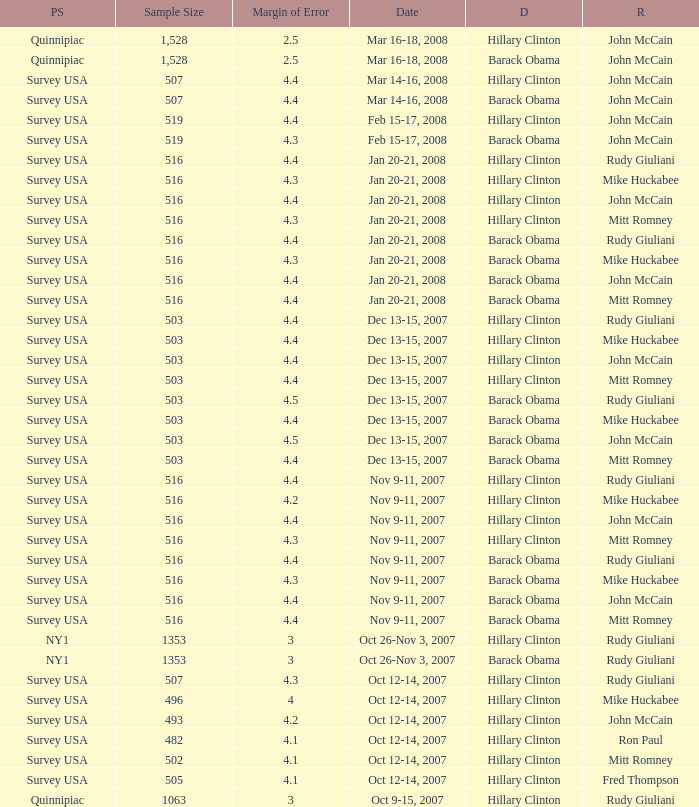Which Democrat was selected in the poll with a sample size smaller than 516 where the Republican chosen was Ron Paul? Hillary Clinton. Can you parse all the data within this table? {'header': ['PS', 'Sample Size', 'Margin of Error', 'Date', 'D', 'R'], 'rows': [['Quinnipiac', '1,528', '2.5', 'Mar 16-18, 2008', 'Hillary Clinton', 'John McCain'], ['Quinnipiac', '1,528', '2.5', 'Mar 16-18, 2008', 'Barack Obama', 'John McCain'], ['Survey USA', '507', '4.4', 'Mar 14-16, 2008', 'Hillary Clinton', 'John McCain'], ['Survey USA', '507', '4.4', 'Mar 14-16, 2008', 'Barack Obama', 'John McCain'], ['Survey USA', '519', '4.4', 'Feb 15-17, 2008', 'Hillary Clinton', 'John McCain'], ['Survey USA', '519', '4.3', 'Feb 15-17, 2008', 'Barack Obama', 'John McCain'], ['Survey USA', '516', '4.4', 'Jan 20-21, 2008', 'Hillary Clinton', 'Rudy Giuliani'], ['Survey USA', '516', '4.3', 'Jan 20-21, 2008', 'Hillary Clinton', 'Mike Huckabee'], ['Survey USA', '516', '4.4', 'Jan 20-21, 2008', 'Hillary Clinton', 'John McCain'], ['Survey USA', '516', '4.3', 'Jan 20-21, 2008', 'Hillary Clinton', 'Mitt Romney'], ['Survey USA', '516', '4.4', 'Jan 20-21, 2008', 'Barack Obama', 'Rudy Giuliani'], ['Survey USA', '516', '4.3', 'Jan 20-21, 2008', 'Barack Obama', 'Mike Huckabee'], ['Survey USA', '516', '4.4', 'Jan 20-21, 2008', 'Barack Obama', 'John McCain'], ['Survey USA', '516', '4.4', 'Jan 20-21, 2008', 'Barack Obama', 'Mitt Romney'], ['Survey USA', '503', '4.4', 'Dec 13-15, 2007', 'Hillary Clinton', 'Rudy Giuliani'], ['Survey USA', '503', '4.4', 'Dec 13-15, 2007', 'Hillary Clinton', 'Mike Huckabee'], ['Survey USA', '503', '4.4', 'Dec 13-15, 2007', 'Hillary Clinton', 'John McCain'], ['Survey USA', '503', '4.4', 'Dec 13-15, 2007', 'Hillary Clinton', 'Mitt Romney'], ['Survey USA', '503', '4.5', 'Dec 13-15, 2007', 'Barack Obama', 'Rudy Giuliani'], ['Survey USA', '503', '4.4', 'Dec 13-15, 2007', 'Barack Obama', 'Mike Huckabee'], ['Survey USA', '503', '4.5', 'Dec 13-15, 2007', 'Barack Obama', 'John McCain'], ['Survey USA', '503', '4.4', 'Dec 13-15, 2007', 'Barack Obama', 'Mitt Romney'], ['Survey USA', '516', '4.4', 'Nov 9-11, 2007', 'Hillary Clinton', 'Rudy Giuliani'], ['Survey USA', '516', '4.2', 'Nov 9-11, 2007', 'Hillary Clinton', 'Mike Huckabee'], ['Survey USA', '516', '4.4', 'Nov 9-11, 2007', 'Hillary Clinton', 'John McCain'], ['Survey USA', '516', '4.3', 'Nov 9-11, 2007', 'Hillary Clinton', 'Mitt Romney'], ['Survey USA', '516', '4.4', 'Nov 9-11, 2007', 'Barack Obama', 'Rudy Giuliani'], ['Survey USA', '516', '4.3', 'Nov 9-11, 2007', 'Barack Obama', 'Mike Huckabee'], ['Survey USA', '516', '4.4', 'Nov 9-11, 2007', 'Barack Obama', 'John McCain'], ['Survey USA', '516', '4.4', 'Nov 9-11, 2007', 'Barack Obama', 'Mitt Romney'], ['NY1', '1353', '3', 'Oct 26-Nov 3, 2007', 'Hillary Clinton', 'Rudy Giuliani'], ['NY1', '1353', '3', 'Oct 26-Nov 3, 2007', 'Barack Obama', 'Rudy Giuliani'], ['Survey USA', '507', '4.3', 'Oct 12-14, 2007', 'Hillary Clinton', 'Rudy Giuliani'], ['Survey USA', '496', '4', 'Oct 12-14, 2007', 'Hillary Clinton', 'Mike Huckabee'], ['Survey USA', '493', '4.2', 'Oct 12-14, 2007', 'Hillary Clinton', 'John McCain'], ['Survey USA', '482', '4.1', 'Oct 12-14, 2007', 'Hillary Clinton', 'Ron Paul'], ['Survey USA', '502', '4.1', 'Oct 12-14, 2007', 'Hillary Clinton', 'Mitt Romney'], ['Survey USA', '505', '4.1', 'Oct 12-14, 2007', 'Hillary Clinton', 'Fred Thompson'], ['Quinnipiac', '1063', '3', 'Oct 9-15, 2007', 'Hillary Clinton', 'Rudy Giuliani']]} 